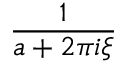Convert formula to latex. <formula><loc_0><loc_0><loc_500><loc_500>\frac { 1 } { a + 2 \pi i \xi }</formula> 